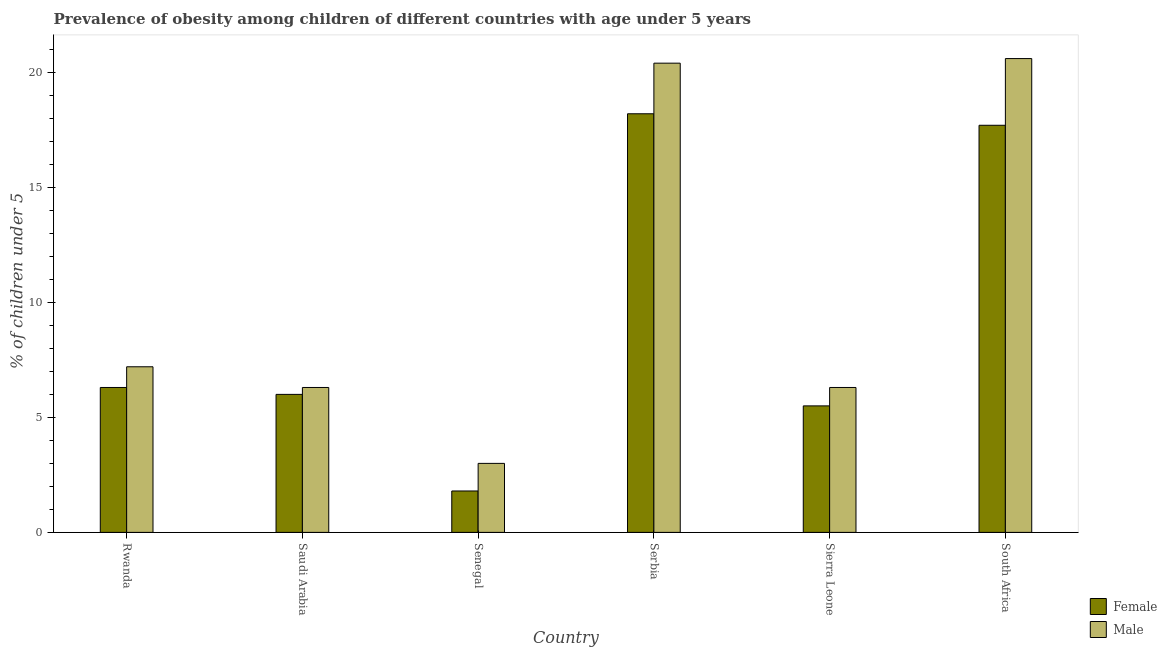How many groups of bars are there?
Your answer should be very brief. 6. Are the number of bars on each tick of the X-axis equal?
Offer a very short reply. Yes. How many bars are there on the 5th tick from the right?
Keep it short and to the point. 2. What is the label of the 4th group of bars from the left?
Offer a terse response. Serbia. In how many cases, is the number of bars for a given country not equal to the number of legend labels?
Your response must be concise. 0. What is the percentage of obese male children in Serbia?
Ensure brevity in your answer.  20.4. Across all countries, what is the maximum percentage of obese female children?
Ensure brevity in your answer.  18.2. In which country was the percentage of obese female children maximum?
Provide a short and direct response. Serbia. In which country was the percentage of obese male children minimum?
Provide a short and direct response. Senegal. What is the total percentage of obese male children in the graph?
Offer a very short reply. 63.8. What is the difference between the percentage of obese male children in Rwanda and that in Serbia?
Provide a short and direct response. -13.2. What is the difference between the percentage of obese male children in Senegal and the percentage of obese female children in Rwanda?
Make the answer very short. -3.3. What is the average percentage of obese female children per country?
Provide a short and direct response. 9.25. What is the difference between the percentage of obese female children and percentage of obese male children in Saudi Arabia?
Your answer should be compact. -0.3. In how many countries, is the percentage of obese female children greater than 8 %?
Offer a terse response. 2. What is the ratio of the percentage of obese male children in Rwanda to that in Sierra Leone?
Offer a terse response. 1.14. What is the difference between the highest and the second highest percentage of obese female children?
Your answer should be very brief. 0.5. What is the difference between the highest and the lowest percentage of obese male children?
Keep it short and to the point. 17.6. In how many countries, is the percentage of obese female children greater than the average percentage of obese female children taken over all countries?
Your answer should be compact. 2. Is the sum of the percentage of obese female children in Sierra Leone and South Africa greater than the maximum percentage of obese male children across all countries?
Provide a short and direct response. Yes. What is the difference between two consecutive major ticks on the Y-axis?
Provide a short and direct response. 5. Are the values on the major ticks of Y-axis written in scientific E-notation?
Give a very brief answer. No. How many legend labels are there?
Give a very brief answer. 2. What is the title of the graph?
Your answer should be very brief. Prevalence of obesity among children of different countries with age under 5 years. Does "Working capital" appear as one of the legend labels in the graph?
Your answer should be compact. No. What is the label or title of the X-axis?
Provide a short and direct response. Country. What is the label or title of the Y-axis?
Your answer should be compact.  % of children under 5. What is the  % of children under 5 in Female in Rwanda?
Keep it short and to the point. 6.3. What is the  % of children under 5 of Male in Rwanda?
Your response must be concise. 7.2. What is the  % of children under 5 in Female in Saudi Arabia?
Make the answer very short. 6. What is the  % of children under 5 in Male in Saudi Arabia?
Offer a very short reply. 6.3. What is the  % of children under 5 in Female in Senegal?
Your response must be concise. 1.8. What is the  % of children under 5 of Female in Serbia?
Offer a terse response. 18.2. What is the  % of children under 5 of Male in Serbia?
Your answer should be compact. 20.4. What is the  % of children under 5 in Female in Sierra Leone?
Offer a terse response. 5.5. What is the  % of children under 5 of Male in Sierra Leone?
Offer a very short reply. 6.3. What is the  % of children under 5 in Female in South Africa?
Your response must be concise. 17.7. What is the  % of children under 5 of Male in South Africa?
Provide a short and direct response. 20.6. Across all countries, what is the maximum  % of children under 5 of Female?
Ensure brevity in your answer.  18.2. Across all countries, what is the maximum  % of children under 5 in Male?
Make the answer very short. 20.6. Across all countries, what is the minimum  % of children under 5 of Female?
Your answer should be compact. 1.8. Across all countries, what is the minimum  % of children under 5 of Male?
Provide a succinct answer. 3. What is the total  % of children under 5 in Female in the graph?
Give a very brief answer. 55.5. What is the total  % of children under 5 in Male in the graph?
Offer a very short reply. 63.8. What is the difference between the  % of children under 5 in Male in Rwanda and that in Saudi Arabia?
Provide a succinct answer. 0.9. What is the difference between the  % of children under 5 of Female in Rwanda and that in Serbia?
Your answer should be very brief. -11.9. What is the difference between the  % of children under 5 of Female in Rwanda and that in Sierra Leone?
Your answer should be compact. 0.8. What is the difference between the  % of children under 5 of Female in Rwanda and that in South Africa?
Give a very brief answer. -11.4. What is the difference between the  % of children under 5 in Male in Rwanda and that in South Africa?
Your response must be concise. -13.4. What is the difference between the  % of children under 5 of Male in Saudi Arabia and that in Senegal?
Keep it short and to the point. 3.3. What is the difference between the  % of children under 5 in Female in Saudi Arabia and that in Serbia?
Ensure brevity in your answer.  -12.2. What is the difference between the  % of children under 5 of Male in Saudi Arabia and that in Serbia?
Offer a terse response. -14.1. What is the difference between the  % of children under 5 of Female in Saudi Arabia and that in Sierra Leone?
Make the answer very short. 0.5. What is the difference between the  % of children under 5 of Male in Saudi Arabia and that in Sierra Leone?
Provide a succinct answer. 0. What is the difference between the  % of children under 5 in Male in Saudi Arabia and that in South Africa?
Give a very brief answer. -14.3. What is the difference between the  % of children under 5 of Female in Senegal and that in Serbia?
Provide a short and direct response. -16.4. What is the difference between the  % of children under 5 of Male in Senegal and that in Serbia?
Offer a very short reply. -17.4. What is the difference between the  % of children under 5 of Female in Senegal and that in Sierra Leone?
Give a very brief answer. -3.7. What is the difference between the  % of children under 5 in Female in Senegal and that in South Africa?
Provide a short and direct response. -15.9. What is the difference between the  % of children under 5 of Male in Senegal and that in South Africa?
Offer a terse response. -17.6. What is the difference between the  % of children under 5 in Female in Serbia and that in Sierra Leone?
Provide a short and direct response. 12.7. What is the difference between the  % of children under 5 in Male in Serbia and that in Sierra Leone?
Your answer should be compact. 14.1. What is the difference between the  % of children under 5 in Female in Serbia and that in South Africa?
Give a very brief answer. 0.5. What is the difference between the  % of children under 5 of Female in Sierra Leone and that in South Africa?
Make the answer very short. -12.2. What is the difference between the  % of children under 5 in Male in Sierra Leone and that in South Africa?
Your answer should be compact. -14.3. What is the difference between the  % of children under 5 in Female in Rwanda and the  % of children under 5 in Male in Saudi Arabia?
Your response must be concise. 0. What is the difference between the  % of children under 5 of Female in Rwanda and the  % of children under 5 of Male in Senegal?
Your answer should be compact. 3.3. What is the difference between the  % of children under 5 in Female in Rwanda and the  % of children under 5 in Male in Serbia?
Your response must be concise. -14.1. What is the difference between the  % of children under 5 in Female in Rwanda and the  % of children under 5 in Male in Sierra Leone?
Provide a short and direct response. 0. What is the difference between the  % of children under 5 of Female in Rwanda and the  % of children under 5 of Male in South Africa?
Keep it short and to the point. -14.3. What is the difference between the  % of children under 5 of Female in Saudi Arabia and the  % of children under 5 of Male in Senegal?
Keep it short and to the point. 3. What is the difference between the  % of children under 5 in Female in Saudi Arabia and the  % of children under 5 in Male in Serbia?
Offer a terse response. -14.4. What is the difference between the  % of children under 5 of Female in Saudi Arabia and the  % of children under 5 of Male in Sierra Leone?
Provide a succinct answer. -0.3. What is the difference between the  % of children under 5 in Female in Saudi Arabia and the  % of children under 5 in Male in South Africa?
Offer a very short reply. -14.6. What is the difference between the  % of children under 5 of Female in Senegal and the  % of children under 5 of Male in Serbia?
Keep it short and to the point. -18.6. What is the difference between the  % of children under 5 in Female in Senegal and the  % of children under 5 in Male in Sierra Leone?
Your answer should be compact. -4.5. What is the difference between the  % of children under 5 of Female in Senegal and the  % of children under 5 of Male in South Africa?
Provide a short and direct response. -18.8. What is the difference between the  % of children under 5 of Female in Serbia and the  % of children under 5 of Male in Sierra Leone?
Provide a succinct answer. 11.9. What is the difference between the  % of children under 5 in Female in Sierra Leone and the  % of children under 5 in Male in South Africa?
Provide a short and direct response. -15.1. What is the average  % of children under 5 in Female per country?
Give a very brief answer. 9.25. What is the average  % of children under 5 of Male per country?
Offer a very short reply. 10.63. What is the difference between the  % of children under 5 in Female and  % of children under 5 in Male in Saudi Arabia?
Your response must be concise. -0.3. What is the difference between the  % of children under 5 of Female and  % of children under 5 of Male in Sierra Leone?
Keep it short and to the point. -0.8. What is the ratio of the  % of children under 5 in Male in Rwanda to that in Senegal?
Your response must be concise. 2.4. What is the ratio of the  % of children under 5 of Female in Rwanda to that in Serbia?
Provide a succinct answer. 0.35. What is the ratio of the  % of children under 5 of Male in Rwanda to that in Serbia?
Give a very brief answer. 0.35. What is the ratio of the  % of children under 5 of Female in Rwanda to that in Sierra Leone?
Give a very brief answer. 1.15. What is the ratio of the  % of children under 5 of Female in Rwanda to that in South Africa?
Offer a very short reply. 0.36. What is the ratio of the  % of children under 5 of Male in Rwanda to that in South Africa?
Your answer should be very brief. 0.35. What is the ratio of the  % of children under 5 of Female in Saudi Arabia to that in Serbia?
Keep it short and to the point. 0.33. What is the ratio of the  % of children under 5 of Male in Saudi Arabia to that in Serbia?
Your answer should be compact. 0.31. What is the ratio of the  % of children under 5 in Female in Saudi Arabia to that in South Africa?
Offer a very short reply. 0.34. What is the ratio of the  % of children under 5 of Male in Saudi Arabia to that in South Africa?
Offer a very short reply. 0.31. What is the ratio of the  % of children under 5 in Female in Senegal to that in Serbia?
Keep it short and to the point. 0.1. What is the ratio of the  % of children under 5 of Male in Senegal to that in Serbia?
Make the answer very short. 0.15. What is the ratio of the  % of children under 5 in Female in Senegal to that in Sierra Leone?
Your response must be concise. 0.33. What is the ratio of the  % of children under 5 in Male in Senegal to that in Sierra Leone?
Your response must be concise. 0.48. What is the ratio of the  % of children under 5 in Female in Senegal to that in South Africa?
Ensure brevity in your answer.  0.1. What is the ratio of the  % of children under 5 in Male in Senegal to that in South Africa?
Keep it short and to the point. 0.15. What is the ratio of the  % of children under 5 of Female in Serbia to that in Sierra Leone?
Keep it short and to the point. 3.31. What is the ratio of the  % of children under 5 of Male in Serbia to that in Sierra Leone?
Your answer should be compact. 3.24. What is the ratio of the  % of children under 5 in Female in Serbia to that in South Africa?
Your answer should be compact. 1.03. What is the ratio of the  % of children under 5 of Male in Serbia to that in South Africa?
Offer a terse response. 0.99. What is the ratio of the  % of children under 5 of Female in Sierra Leone to that in South Africa?
Keep it short and to the point. 0.31. What is the ratio of the  % of children under 5 of Male in Sierra Leone to that in South Africa?
Provide a succinct answer. 0.31. What is the difference between the highest and the lowest  % of children under 5 in Male?
Your answer should be very brief. 17.6. 